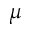Convert formula to latex. <formula><loc_0><loc_0><loc_500><loc_500>\mu</formula> 